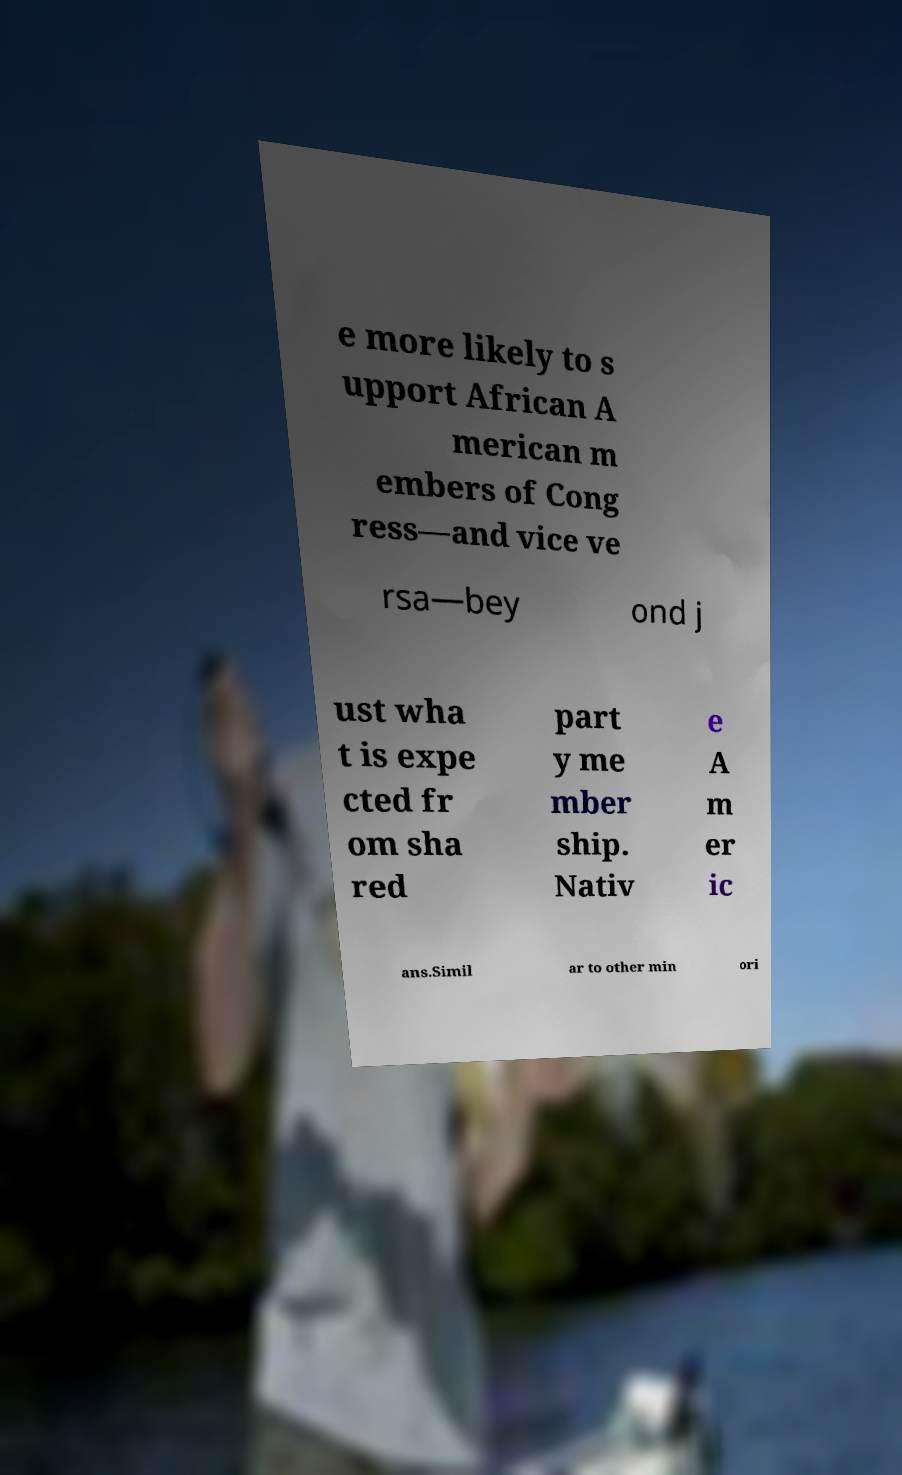There's text embedded in this image that I need extracted. Can you transcribe it verbatim? e more likely to s upport African A merican m embers of Cong ress—and vice ve rsa—bey ond j ust wha t is expe cted fr om sha red part y me mber ship. Nativ e A m er ic ans.Simil ar to other min ori 